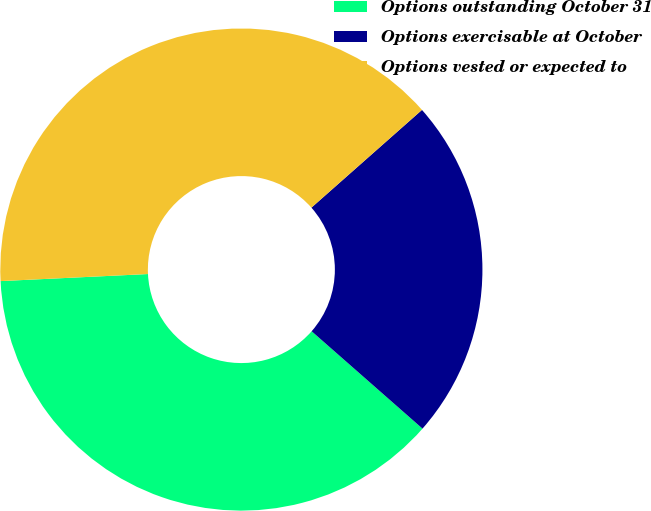Convert chart to OTSL. <chart><loc_0><loc_0><loc_500><loc_500><pie_chart><fcel>Options outstanding October 31<fcel>Options exercisable at October<fcel>Options vested or expected to<nl><fcel>37.77%<fcel>22.99%<fcel>39.24%<nl></chart> 